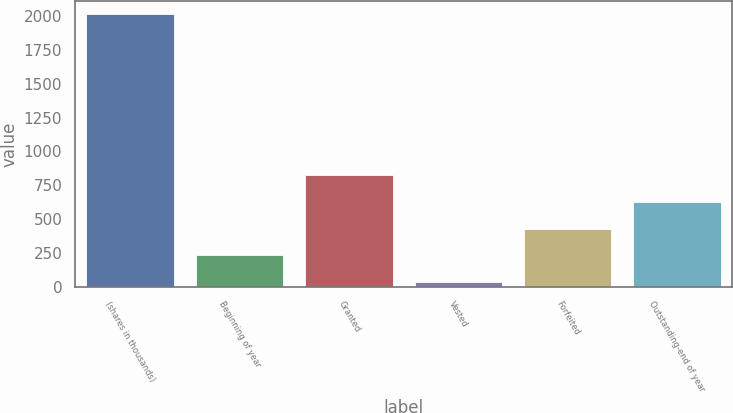<chart> <loc_0><loc_0><loc_500><loc_500><bar_chart><fcel>(shares in thousands)<fcel>Beginning of year<fcel>Granted<fcel>Vested<fcel>Forfeited<fcel>Outstanding-end of year<nl><fcel>2011<fcel>231.74<fcel>824.84<fcel>34.04<fcel>429.44<fcel>627.14<nl></chart> 